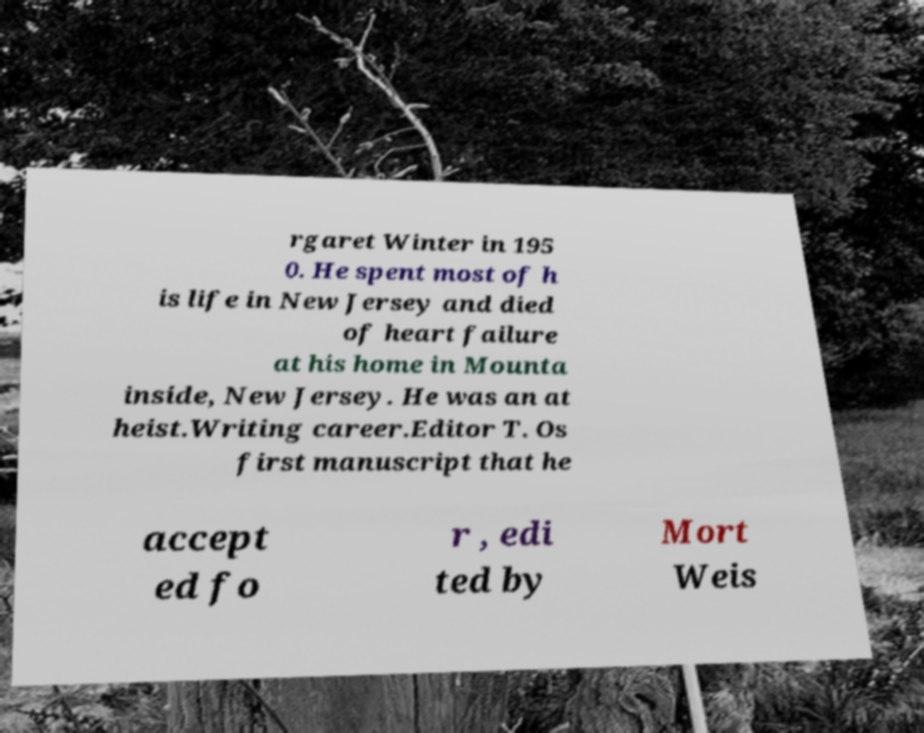Please identify and transcribe the text found in this image. rgaret Winter in 195 0. He spent most of h is life in New Jersey and died of heart failure at his home in Mounta inside, New Jersey. He was an at heist.Writing career.Editor T. Os first manuscript that he accept ed fo r , edi ted by Mort Weis 